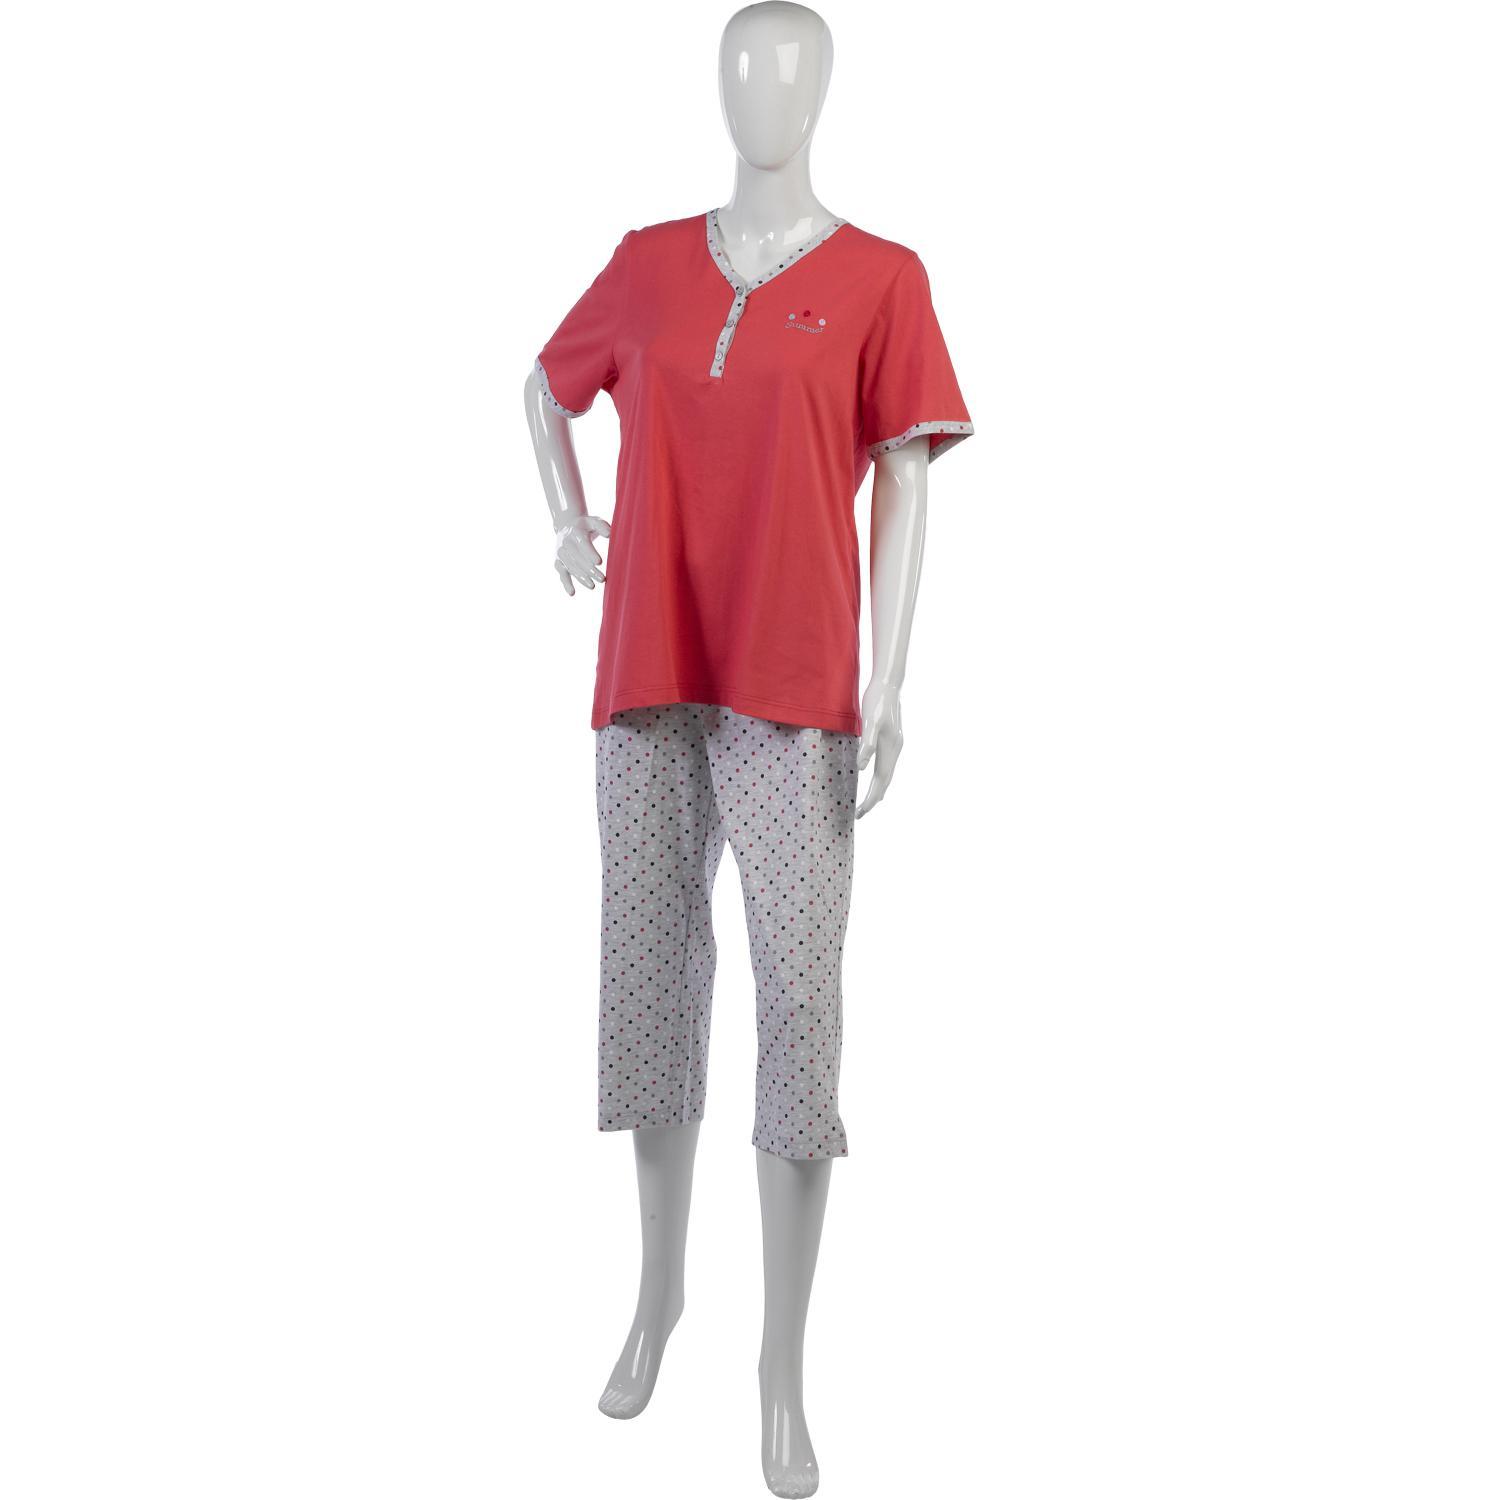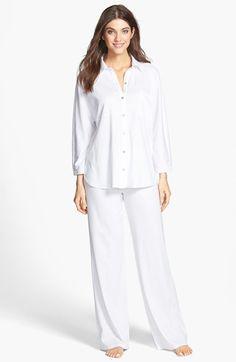The first image is the image on the left, the second image is the image on the right. For the images displayed, is the sentence "At least one pair of pajamas are polka-dotted." factually correct? Answer yes or no. No. The first image is the image on the left, the second image is the image on the right. Examine the images to the left and right. Is the description "The image on the left has a mannequin wearing sleep attire." accurate? Answer yes or no. Yes. 